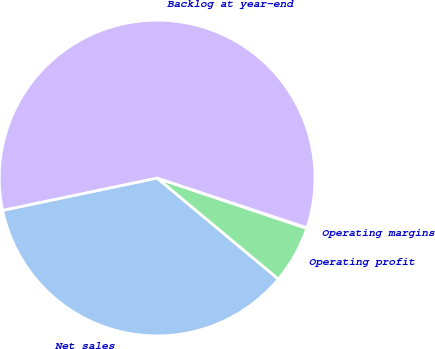<chart> <loc_0><loc_0><loc_500><loc_500><pie_chart><fcel>Net sales<fcel>Operating profit<fcel>Operating margins<fcel>Backlog at year-end<nl><fcel>35.66%<fcel>5.89%<fcel>0.06%<fcel>58.38%<nl></chart> 